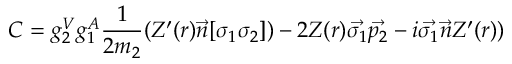<formula> <loc_0><loc_0><loc_500><loc_500>C = g _ { 2 } ^ { V } g _ { 1 } ^ { A } \frac { 1 } { 2 m _ { 2 } } ( Z ^ { \prime } ( r ) \vec { n } [ \sigma _ { 1 } \sigma _ { 2 } ] ) - 2 Z ( r ) \vec { \sigma _ { 1 } } \vec { p _ { 2 } } - i \vec { \sigma _ { 1 } } \vec { n } Z ^ { \prime } ( r ) )</formula> 